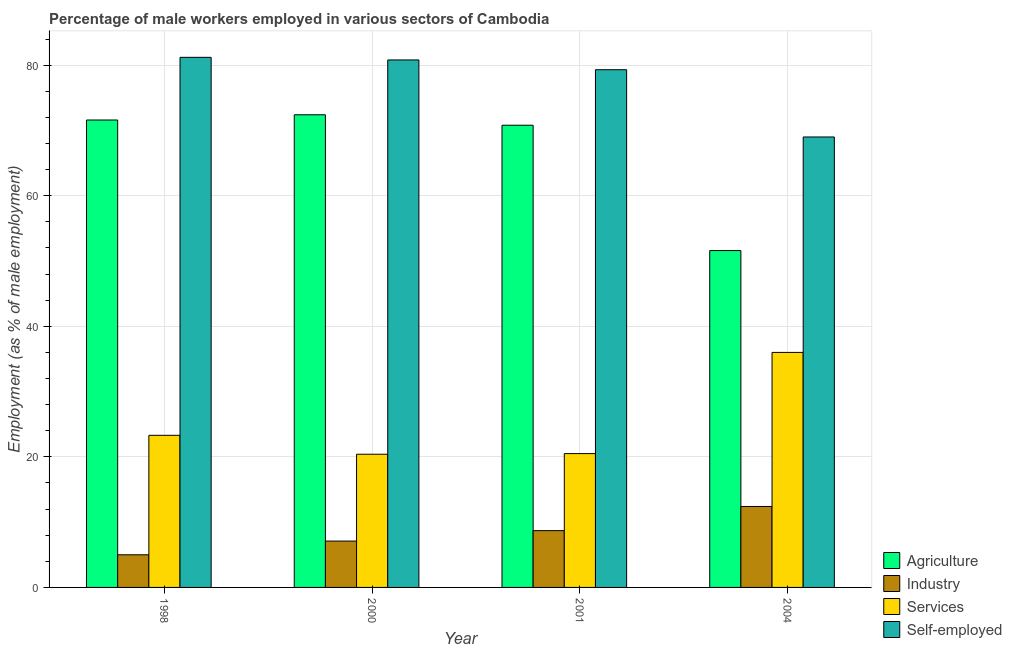How many different coloured bars are there?
Your answer should be compact. 4. Are the number of bars per tick equal to the number of legend labels?
Ensure brevity in your answer.  Yes. Are the number of bars on each tick of the X-axis equal?
Make the answer very short. Yes. How many bars are there on the 1st tick from the right?
Provide a succinct answer. 4. What is the label of the 4th group of bars from the left?
Your answer should be very brief. 2004. In how many cases, is the number of bars for a given year not equal to the number of legend labels?
Your answer should be very brief. 0. What is the percentage of self employed male workers in 1998?
Ensure brevity in your answer.  81.2. Across all years, what is the maximum percentage of self employed male workers?
Make the answer very short. 81.2. Across all years, what is the minimum percentage of male workers in services?
Provide a succinct answer. 20.4. In which year was the percentage of male workers in industry minimum?
Your answer should be very brief. 1998. What is the total percentage of male workers in services in the graph?
Make the answer very short. 100.2. What is the difference between the percentage of self employed male workers in 1998 and that in 2004?
Offer a terse response. 12.2. What is the difference between the percentage of male workers in services in 2004 and the percentage of male workers in agriculture in 1998?
Keep it short and to the point. 12.7. What is the average percentage of male workers in industry per year?
Keep it short and to the point. 8.3. What is the ratio of the percentage of self employed male workers in 1998 to that in 2000?
Your response must be concise. 1. Is the percentage of male workers in agriculture in 1998 less than that in 2001?
Provide a succinct answer. No. Is the difference between the percentage of male workers in industry in 1998 and 2004 greater than the difference between the percentage of male workers in services in 1998 and 2004?
Provide a short and direct response. No. What is the difference between the highest and the second highest percentage of male workers in agriculture?
Make the answer very short. 0.8. What is the difference between the highest and the lowest percentage of male workers in services?
Your response must be concise. 15.6. In how many years, is the percentage of male workers in industry greater than the average percentage of male workers in industry taken over all years?
Ensure brevity in your answer.  2. Is the sum of the percentage of male workers in agriculture in 1998 and 2000 greater than the maximum percentage of male workers in industry across all years?
Provide a short and direct response. Yes. What does the 1st bar from the left in 1998 represents?
Your answer should be very brief. Agriculture. What does the 3rd bar from the right in 1998 represents?
Keep it short and to the point. Industry. Is it the case that in every year, the sum of the percentage of male workers in agriculture and percentage of male workers in industry is greater than the percentage of male workers in services?
Keep it short and to the point. Yes. Are all the bars in the graph horizontal?
Make the answer very short. No. Does the graph contain any zero values?
Offer a terse response. No. Does the graph contain grids?
Make the answer very short. Yes. Where does the legend appear in the graph?
Give a very brief answer. Bottom right. How many legend labels are there?
Your answer should be very brief. 4. What is the title of the graph?
Offer a very short reply. Percentage of male workers employed in various sectors of Cambodia. Does "Services" appear as one of the legend labels in the graph?
Your answer should be very brief. Yes. What is the label or title of the X-axis?
Your response must be concise. Year. What is the label or title of the Y-axis?
Your answer should be compact. Employment (as % of male employment). What is the Employment (as % of male employment) of Agriculture in 1998?
Give a very brief answer. 71.6. What is the Employment (as % of male employment) of Industry in 1998?
Offer a very short reply. 5. What is the Employment (as % of male employment) in Services in 1998?
Your response must be concise. 23.3. What is the Employment (as % of male employment) in Self-employed in 1998?
Give a very brief answer. 81.2. What is the Employment (as % of male employment) in Agriculture in 2000?
Make the answer very short. 72.4. What is the Employment (as % of male employment) in Industry in 2000?
Your answer should be compact. 7.1. What is the Employment (as % of male employment) of Services in 2000?
Offer a terse response. 20.4. What is the Employment (as % of male employment) of Self-employed in 2000?
Your response must be concise. 80.8. What is the Employment (as % of male employment) in Agriculture in 2001?
Ensure brevity in your answer.  70.8. What is the Employment (as % of male employment) in Industry in 2001?
Provide a short and direct response. 8.7. What is the Employment (as % of male employment) of Services in 2001?
Provide a short and direct response. 20.5. What is the Employment (as % of male employment) in Self-employed in 2001?
Make the answer very short. 79.3. What is the Employment (as % of male employment) of Agriculture in 2004?
Offer a very short reply. 51.6. What is the Employment (as % of male employment) of Industry in 2004?
Give a very brief answer. 12.4. What is the Employment (as % of male employment) in Services in 2004?
Give a very brief answer. 36. What is the Employment (as % of male employment) in Self-employed in 2004?
Offer a terse response. 69. Across all years, what is the maximum Employment (as % of male employment) in Agriculture?
Provide a succinct answer. 72.4. Across all years, what is the maximum Employment (as % of male employment) in Industry?
Give a very brief answer. 12.4. Across all years, what is the maximum Employment (as % of male employment) in Services?
Your answer should be very brief. 36. Across all years, what is the maximum Employment (as % of male employment) in Self-employed?
Offer a very short reply. 81.2. Across all years, what is the minimum Employment (as % of male employment) of Agriculture?
Ensure brevity in your answer.  51.6. Across all years, what is the minimum Employment (as % of male employment) in Industry?
Your answer should be very brief. 5. Across all years, what is the minimum Employment (as % of male employment) of Services?
Provide a succinct answer. 20.4. What is the total Employment (as % of male employment) in Agriculture in the graph?
Your answer should be very brief. 266.4. What is the total Employment (as % of male employment) in Industry in the graph?
Keep it short and to the point. 33.2. What is the total Employment (as % of male employment) in Services in the graph?
Provide a succinct answer. 100.2. What is the total Employment (as % of male employment) in Self-employed in the graph?
Offer a terse response. 310.3. What is the difference between the Employment (as % of male employment) of Services in 1998 and that in 2000?
Provide a short and direct response. 2.9. What is the difference between the Employment (as % of male employment) of Agriculture in 1998 and that in 2001?
Provide a succinct answer. 0.8. What is the difference between the Employment (as % of male employment) in Industry in 1998 and that in 2001?
Your response must be concise. -3.7. What is the difference between the Employment (as % of male employment) in Agriculture in 1998 and that in 2004?
Your answer should be compact. 20. What is the difference between the Employment (as % of male employment) of Industry in 1998 and that in 2004?
Offer a very short reply. -7.4. What is the difference between the Employment (as % of male employment) of Services in 1998 and that in 2004?
Make the answer very short. -12.7. What is the difference between the Employment (as % of male employment) in Self-employed in 1998 and that in 2004?
Provide a succinct answer. 12.2. What is the difference between the Employment (as % of male employment) in Industry in 2000 and that in 2001?
Provide a succinct answer. -1.6. What is the difference between the Employment (as % of male employment) of Services in 2000 and that in 2001?
Make the answer very short. -0.1. What is the difference between the Employment (as % of male employment) in Self-employed in 2000 and that in 2001?
Your response must be concise. 1.5. What is the difference between the Employment (as % of male employment) in Agriculture in 2000 and that in 2004?
Your response must be concise. 20.8. What is the difference between the Employment (as % of male employment) of Industry in 2000 and that in 2004?
Offer a very short reply. -5.3. What is the difference between the Employment (as % of male employment) of Services in 2000 and that in 2004?
Your answer should be very brief. -15.6. What is the difference between the Employment (as % of male employment) of Self-employed in 2000 and that in 2004?
Your response must be concise. 11.8. What is the difference between the Employment (as % of male employment) in Agriculture in 2001 and that in 2004?
Make the answer very short. 19.2. What is the difference between the Employment (as % of male employment) in Services in 2001 and that in 2004?
Your answer should be very brief. -15.5. What is the difference between the Employment (as % of male employment) in Self-employed in 2001 and that in 2004?
Offer a very short reply. 10.3. What is the difference between the Employment (as % of male employment) of Agriculture in 1998 and the Employment (as % of male employment) of Industry in 2000?
Give a very brief answer. 64.5. What is the difference between the Employment (as % of male employment) of Agriculture in 1998 and the Employment (as % of male employment) of Services in 2000?
Offer a very short reply. 51.2. What is the difference between the Employment (as % of male employment) of Agriculture in 1998 and the Employment (as % of male employment) of Self-employed in 2000?
Keep it short and to the point. -9.2. What is the difference between the Employment (as % of male employment) of Industry in 1998 and the Employment (as % of male employment) of Services in 2000?
Keep it short and to the point. -15.4. What is the difference between the Employment (as % of male employment) in Industry in 1998 and the Employment (as % of male employment) in Self-employed in 2000?
Provide a short and direct response. -75.8. What is the difference between the Employment (as % of male employment) in Services in 1998 and the Employment (as % of male employment) in Self-employed in 2000?
Your answer should be very brief. -57.5. What is the difference between the Employment (as % of male employment) in Agriculture in 1998 and the Employment (as % of male employment) in Industry in 2001?
Your response must be concise. 62.9. What is the difference between the Employment (as % of male employment) in Agriculture in 1998 and the Employment (as % of male employment) in Services in 2001?
Provide a short and direct response. 51.1. What is the difference between the Employment (as % of male employment) in Agriculture in 1998 and the Employment (as % of male employment) in Self-employed in 2001?
Keep it short and to the point. -7.7. What is the difference between the Employment (as % of male employment) in Industry in 1998 and the Employment (as % of male employment) in Services in 2001?
Your response must be concise. -15.5. What is the difference between the Employment (as % of male employment) in Industry in 1998 and the Employment (as % of male employment) in Self-employed in 2001?
Offer a very short reply. -74.3. What is the difference between the Employment (as % of male employment) in Services in 1998 and the Employment (as % of male employment) in Self-employed in 2001?
Offer a very short reply. -56. What is the difference between the Employment (as % of male employment) in Agriculture in 1998 and the Employment (as % of male employment) in Industry in 2004?
Provide a short and direct response. 59.2. What is the difference between the Employment (as % of male employment) of Agriculture in 1998 and the Employment (as % of male employment) of Services in 2004?
Give a very brief answer. 35.6. What is the difference between the Employment (as % of male employment) of Agriculture in 1998 and the Employment (as % of male employment) of Self-employed in 2004?
Provide a short and direct response. 2.6. What is the difference between the Employment (as % of male employment) in Industry in 1998 and the Employment (as % of male employment) in Services in 2004?
Your response must be concise. -31. What is the difference between the Employment (as % of male employment) in Industry in 1998 and the Employment (as % of male employment) in Self-employed in 2004?
Offer a very short reply. -64. What is the difference between the Employment (as % of male employment) of Services in 1998 and the Employment (as % of male employment) of Self-employed in 2004?
Your answer should be very brief. -45.7. What is the difference between the Employment (as % of male employment) in Agriculture in 2000 and the Employment (as % of male employment) in Industry in 2001?
Provide a succinct answer. 63.7. What is the difference between the Employment (as % of male employment) in Agriculture in 2000 and the Employment (as % of male employment) in Services in 2001?
Make the answer very short. 51.9. What is the difference between the Employment (as % of male employment) of Industry in 2000 and the Employment (as % of male employment) of Services in 2001?
Provide a short and direct response. -13.4. What is the difference between the Employment (as % of male employment) of Industry in 2000 and the Employment (as % of male employment) of Self-employed in 2001?
Provide a succinct answer. -72.2. What is the difference between the Employment (as % of male employment) in Services in 2000 and the Employment (as % of male employment) in Self-employed in 2001?
Ensure brevity in your answer.  -58.9. What is the difference between the Employment (as % of male employment) of Agriculture in 2000 and the Employment (as % of male employment) of Industry in 2004?
Offer a terse response. 60. What is the difference between the Employment (as % of male employment) in Agriculture in 2000 and the Employment (as % of male employment) in Services in 2004?
Keep it short and to the point. 36.4. What is the difference between the Employment (as % of male employment) of Industry in 2000 and the Employment (as % of male employment) of Services in 2004?
Your answer should be compact. -28.9. What is the difference between the Employment (as % of male employment) in Industry in 2000 and the Employment (as % of male employment) in Self-employed in 2004?
Keep it short and to the point. -61.9. What is the difference between the Employment (as % of male employment) in Services in 2000 and the Employment (as % of male employment) in Self-employed in 2004?
Ensure brevity in your answer.  -48.6. What is the difference between the Employment (as % of male employment) in Agriculture in 2001 and the Employment (as % of male employment) in Industry in 2004?
Provide a succinct answer. 58.4. What is the difference between the Employment (as % of male employment) in Agriculture in 2001 and the Employment (as % of male employment) in Services in 2004?
Offer a terse response. 34.8. What is the difference between the Employment (as % of male employment) in Agriculture in 2001 and the Employment (as % of male employment) in Self-employed in 2004?
Provide a short and direct response. 1.8. What is the difference between the Employment (as % of male employment) of Industry in 2001 and the Employment (as % of male employment) of Services in 2004?
Keep it short and to the point. -27.3. What is the difference between the Employment (as % of male employment) of Industry in 2001 and the Employment (as % of male employment) of Self-employed in 2004?
Ensure brevity in your answer.  -60.3. What is the difference between the Employment (as % of male employment) of Services in 2001 and the Employment (as % of male employment) of Self-employed in 2004?
Offer a very short reply. -48.5. What is the average Employment (as % of male employment) of Agriculture per year?
Provide a succinct answer. 66.6. What is the average Employment (as % of male employment) of Industry per year?
Your answer should be compact. 8.3. What is the average Employment (as % of male employment) of Services per year?
Your answer should be compact. 25.05. What is the average Employment (as % of male employment) of Self-employed per year?
Ensure brevity in your answer.  77.58. In the year 1998, what is the difference between the Employment (as % of male employment) of Agriculture and Employment (as % of male employment) of Industry?
Provide a succinct answer. 66.6. In the year 1998, what is the difference between the Employment (as % of male employment) of Agriculture and Employment (as % of male employment) of Services?
Your response must be concise. 48.3. In the year 1998, what is the difference between the Employment (as % of male employment) of Industry and Employment (as % of male employment) of Services?
Your answer should be compact. -18.3. In the year 1998, what is the difference between the Employment (as % of male employment) of Industry and Employment (as % of male employment) of Self-employed?
Your answer should be compact. -76.2. In the year 1998, what is the difference between the Employment (as % of male employment) of Services and Employment (as % of male employment) of Self-employed?
Make the answer very short. -57.9. In the year 2000, what is the difference between the Employment (as % of male employment) in Agriculture and Employment (as % of male employment) in Industry?
Give a very brief answer. 65.3. In the year 2000, what is the difference between the Employment (as % of male employment) in Agriculture and Employment (as % of male employment) in Services?
Your answer should be compact. 52. In the year 2000, what is the difference between the Employment (as % of male employment) of Industry and Employment (as % of male employment) of Self-employed?
Give a very brief answer. -73.7. In the year 2000, what is the difference between the Employment (as % of male employment) of Services and Employment (as % of male employment) of Self-employed?
Your answer should be compact. -60.4. In the year 2001, what is the difference between the Employment (as % of male employment) of Agriculture and Employment (as % of male employment) of Industry?
Provide a short and direct response. 62.1. In the year 2001, what is the difference between the Employment (as % of male employment) of Agriculture and Employment (as % of male employment) of Services?
Your response must be concise. 50.3. In the year 2001, what is the difference between the Employment (as % of male employment) in Industry and Employment (as % of male employment) in Self-employed?
Offer a very short reply. -70.6. In the year 2001, what is the difference between the Employment (as % of male employment) in Services and Employment (as % of male employment) in Self-employed?
Your response must be concise. -58.8. In the year 2004, what is the difference between the Employment (as % of male employment) in Agriculture and Employment (as % of male employment) in Industry?
Keep it short and to the point. 39.2. In the year 2004, what is the difference between the Employment (as % of male employment) in Agriculture and Employment (as % of male employment) in Services?
Your answer should be very brief. 15.6. In the year 2004, what is the difference between the Employment (as % of male employment) in Agriculture and Employment (as % of male employment) in Self-employed?
Your response must be concise. -17.4. In the year 2004, what is the difference between the Employment (as % of male employment) of Industry and Employment (as % of male employment) of Services?
Your answer should be very brief. -23.6. In the year 2004, what is the difference between the Employment (as % of male employment) of Industry and Employment (as % of male employment) of Self-employed?
Make the answer very short. -56.6. In the year 2004, what is the difference between the Employment (as % of male employment) of Services and Employment (as % of male employment) of Self-employed?
Offer a terse response. -33. What is the ratio of the Employment (as % of male employment) in Industry in 1998 to that in 2000?
Offer a very short reply. 0.7. What is the ratio of the Employment (as % of male employment) in Services in 1998 to that in 2000?
Provide a short and direct response. 1.14. What is the ratio of the Employment (as % of male employment) in Agriculture in 1998 to that in 2001?
Ensure brevity in your answer.  1.01. What is the ratio of the Employment (as % of male employment) of Industry in 1998 to that in 2001?
Make the answer very short. 0.57. What is the ratio of the Employment (as % of male employment) of Services in 1998 to that in 2001?
Your answer should be compact. 1.14. What is the ratio of the Employment (as % of male employment) of Self-employed in 1998 to that in 2001?
Ensure brevity in your answer.  1.02. What is the ratio of the Employment (as % of male employment) in Agriculture in 1998 to that in 2004?
Offer a very short reply. 1.39. What is the ratio of the Employment (as % of male employment) in Industry in 1998 to that in 2004?
Give a very brief answer. 0.4. What is the ratio of the Employment (as % of male employment) in Services in 1998 to that in 2004?
Ensure brevity in your answer.  0.65. What is the ratio of the Employment (as % of male employment) of Self-employed in 1998 to that in 2004?
Give a very brief answer. 1.18. What is the ratio of the Employment (as % of male employment) of Agriculture in 2000 to that in 2001?
Your answer should be compact. 1.02. What is the ratio of the Employment (as % of male employment) in Industry in 2000 to that in 2001?
Make the answer very short. 0.82. What is the ratio of the Employment (as % of male employment) of Services in 2000 to that in 2001?
Make the answer very short. 1. What is the ratio of the Employment (as % of male employment) in Self-employed in 2000 to that in 2001?
Offer a very short reply. 1.02. What is the ratio of the Employment (as % of male employment) in Agriculture in 2000 to that in 2004?
Give a very brief answer. 1.4. What is the ratio of the Employment (as % of male employment) in Industry in 2000 to that in 2004?
Offer a very short reply. 0.57. What is the ratio of the Employment (as % of male employment) of Services in 2000 to that in 2004?
Provide a succinct answer. 0.57. What is the ratio of the Employment (as % of male employment) of Self-employed in 2000 to that in 2004?
Offer a terse response. 1.17. What is the ratio of the Employment (as % of male employment) in Agriculture in 2001 to that in 2004?
Your answer should be very brief. 1.37. What is the ratio of the Employment (as % of male employment) in Industry in 2001 to that in 2004?
Your response must be concise. 0.7. What is the ratio of the Employment (as % of male employment) in Services in 2001 to that in 2004?
Give a very brief answer. 0.57. What is the ratio of the Employment (as % of male employment) in Self-employed in 2001 to that in 2004?
Your answer should be very brief. 1.15. What is the difference between the highest and the second highest Employment (as % of male employment) of Industry?
Keep it short and to the point. 3.7. What is the difference between the highest and the second highest Employment (as % of male employment) in Services?
Provide a succinct answer. 12.7. What is the difference between the highest and the lowest Employment (as % of male employment) of Agriculture?
Provide a succinct answer. 20.8. What is the difference between the highest and the lowest Employment (as % of male employment) in Industry?
Provide a short and direct response. 7.4. What is the difference between the highest and the lowest Employment (as % of male employment) in Services?
Keep it short and to the point. 15.6. 